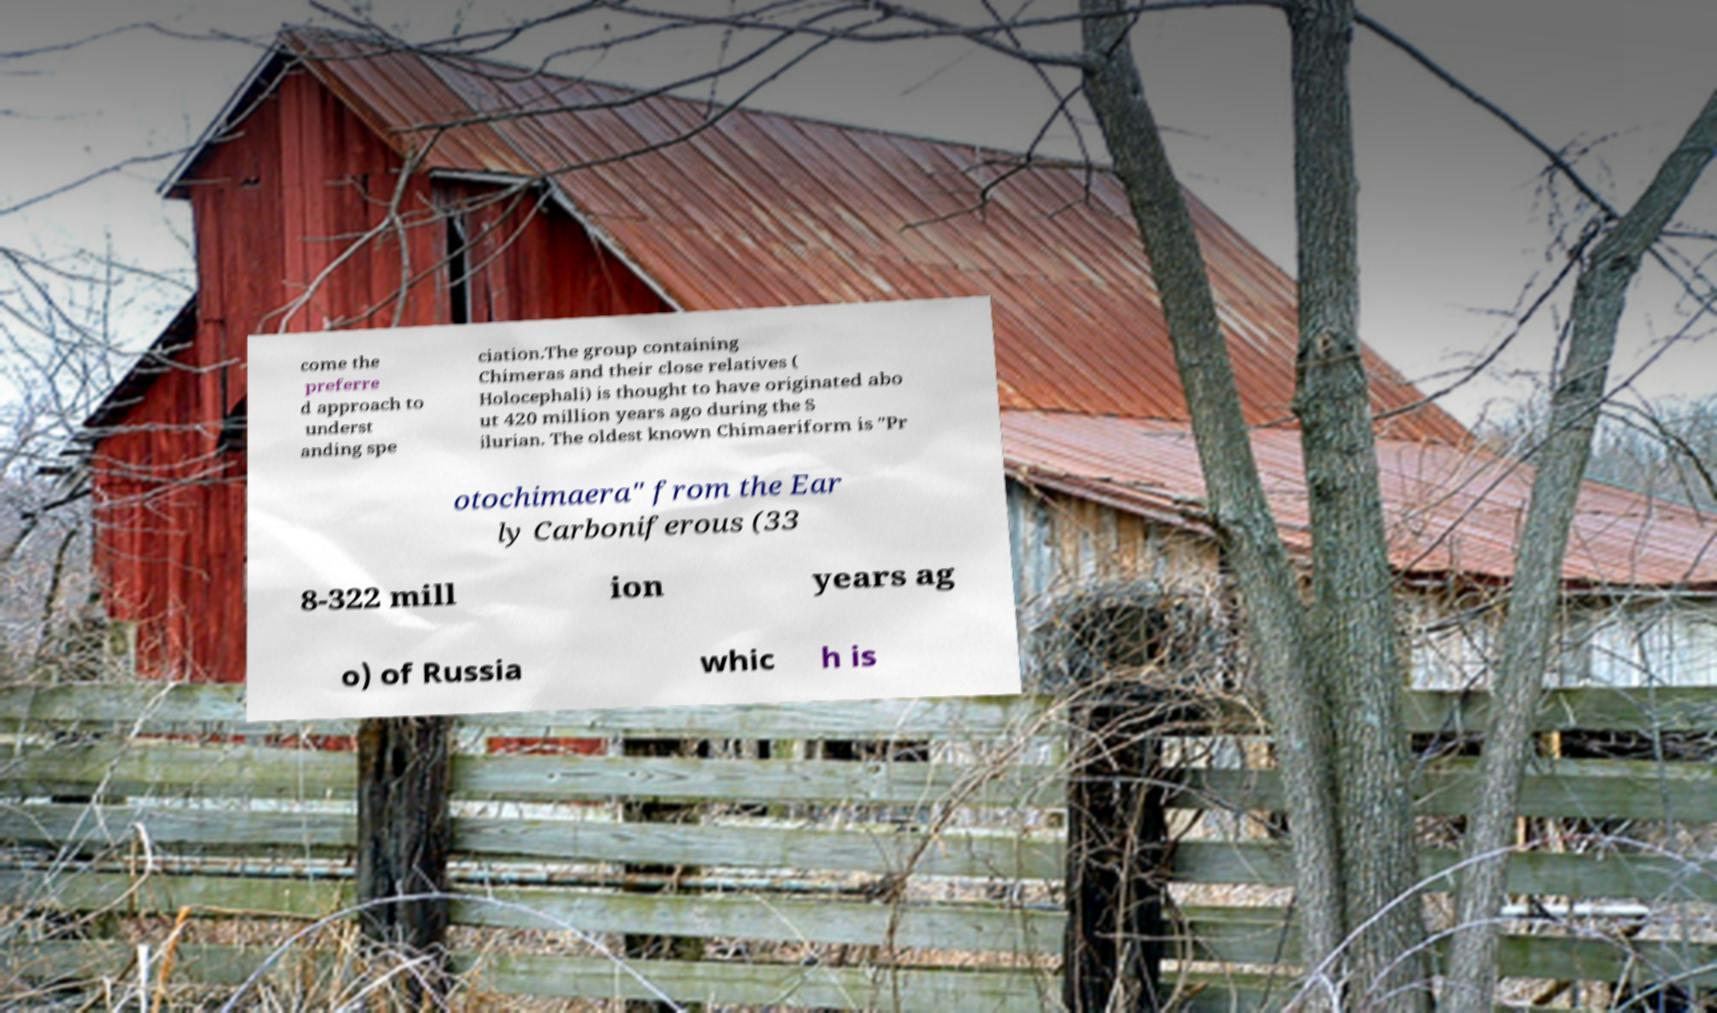Please identify and transcribe the text found in this image. come the preferre d approach to underst anding spe ciation.The group containing Chimeras and their close relatives ( Holocephali) is thought to have originated abo ut 420 million years ago during the S ilurian. The oldest known Chimaeriform is "Pr otochimaera" from the Ear ly Carboniferous (33 8-322 mill ion years ag o) of Russia whic h is 